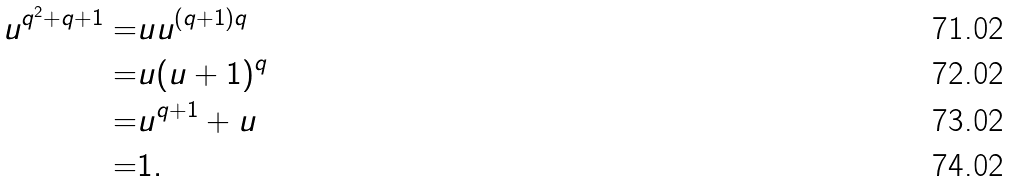<formula> <loc_0><loc_0><loc_500><loc_500>u ^ { q ^ { 2 } + q + 1 } = & u u ^ { ( q + 1 ) q } \\ = & u ( u + 1 ) ^ { q } \\ = & u ^ { q + 1 } + u \\ = & 1 .</formula> 